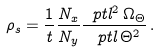Convert formula to latex. <formula><loc_0><loc_0><loc_500><loc_500>\rho _ { s } = \frac { 1 } { t } \frac { N _ { x } } { N _ { y } } \frac { \ p t l ^ { 2 } \, \Omega _ { \Theta } } { \ p t l \, \Theta ^ { 2 } } \, .</formula> 